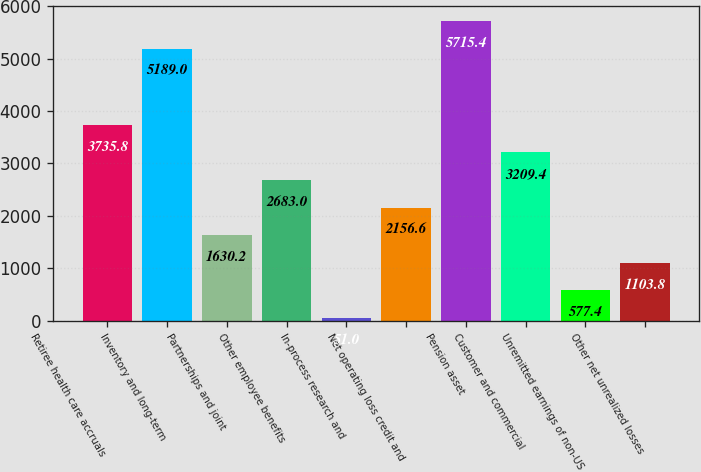Convert chart to OTSL. <chart><loc_0><loc_0><loc_500><loc_500><bar_chart><fcel>Retiree health care accruals<fcel>Inventory and long-term<fcel>Partnerships and joint<fcel>Other employee benefits<fcel>In-process research and<fcel>Net operating loss credit and<fcel>Pension asset<fcel>Customer and commercial<fcel>Unremitted earnings of non-US<fcel>Other net unrealized losses<nl><fcel>3735.8<fcel>5189<fcel>1630.2<fcel>2683<fcel>51<fcel>2156.6<fcel>5715.4<fcel>3209.4<fcel>577.4<fcel>1103.8<nl></chart> 